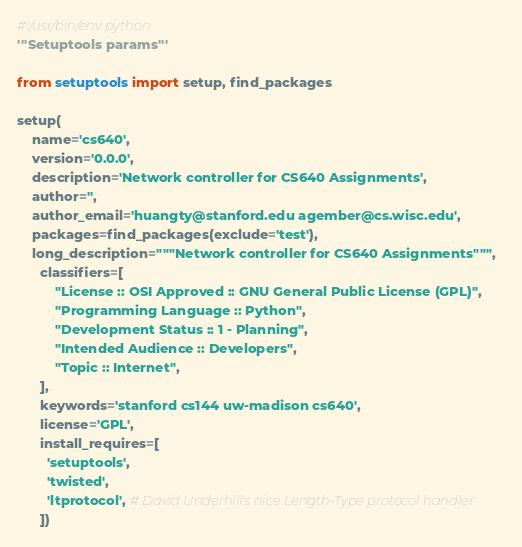<code> <loc_0><loc_0><loc_500><loc_500><_Python_>#!/usr/bin/env python
'''Setuptools params'''

from setuptools import setup, find_packages

setup(
    name='cs640',
    version='0.0.0',
    description='Network controller for CS640 Assignments',
    author='',
    author_email='huangty@stanford.edu agember@cs.wisc.edu',
    packages=find_packages(exclude='test'),
    long_description="""Network controller for CS640 Assignments""",
      classifiers=[
          "License :: OSI Approved :: GNU General Public License (GPL)",
          "Programming Language :: Python",
          "Development Status :: 1 - Planning",
          "Intended Audience :: Developers",
          "Topic :: Internet",
      ],
      keywords='stanford cs144 uw-madison cs640',
      license='GPL',
      install_requires=[
        'setuptools',
        'twisted',
        'ltprotocol', # David Underhill's nice Length-Type protocol handler
      ])

</code> 